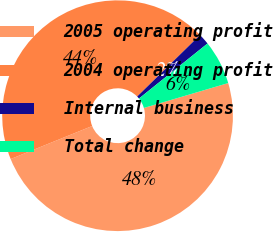Convert chart. <chart><loc_0><loc_0><loc_500><loc_500><pie_chart><fcel>2005 operating profit<fcel>2004 operating profit<fcel>Internal business<fcel>Total change<nl><fcel>48.44%<fcel>43.8%<fcel>1.56%<fcel>6.2%<nl></chart> 